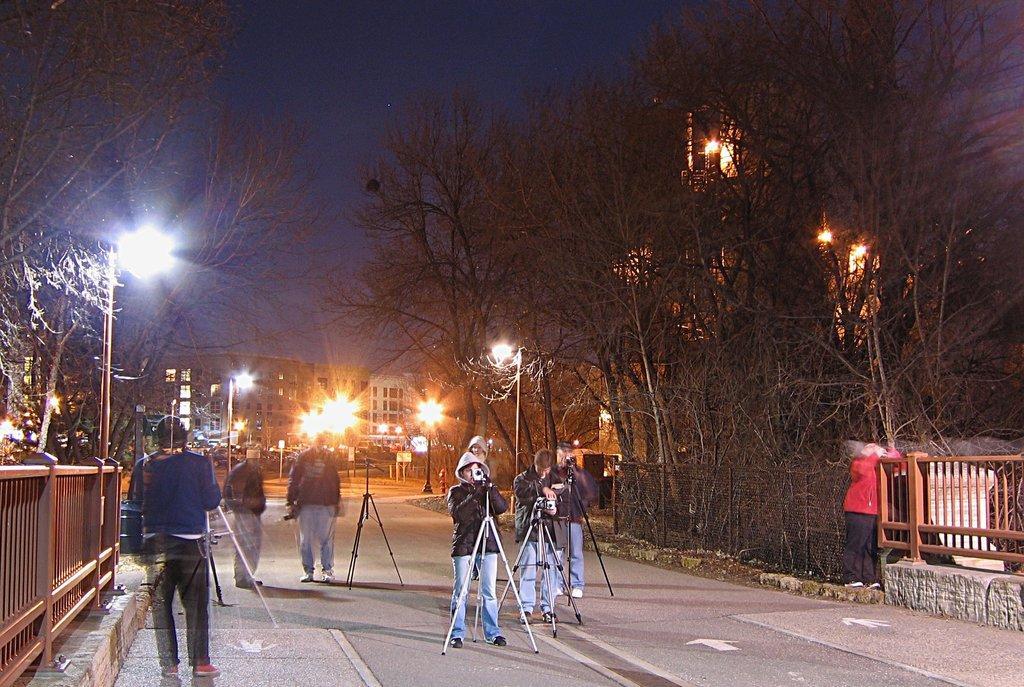How would you summarize this image in a sentence or two? In this image we can see people and some of them are holding cameras. There are stands. We can see railings. In the background there are trees, poles, lights, buildings and sky. 